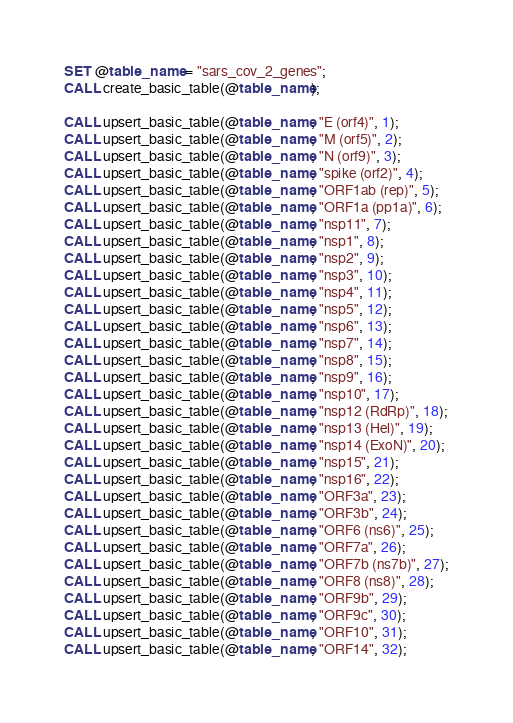Convert code to text. <code><loc_0><loc_0><loc_500><loc_500><_SQL_>SET @table_name = "sars_cov_2_genes";
CALL create_basic_table(@table_name);

CALL upsert_basic_table(@table_name, "E (orf4)", 1);
CALL upsert_basic_table(@table_name, "M (orf5)", 2);
CALL upsert_basic_table(@table_name, "N (orf9)", 3);
CALL upsert_basic_table(@table_name, "spike (orf2)", 4);
CALL upsert_basic_table(@table_name, "ORF1ab (rep)", 5);
CALL upsert_basic_table(@table_name, "ORF1a (pp1a)", 6);
CALL upsert_basic_table(@table_name, "nsp11", 7);
CALL upsert_basic_table(@table_name, "nsp1", 8);
CALL upsert_basic_table(@table_name, "nsp2", 9);
CALL upsert_basic_table(@table_name, "nsp3", 10);
CALL upsert_basic_table(@table_name, "nsp4", 11);
CALL upsert_basic_table(@table_name, "nsp5", 12);
CALL upsert_basic_table(@table_name, "nsp6", 13);
CALL upsert_basic_table(@table_name, "nsp7", 14);
CALL upsert_basic_table(@table_name, "nsp8", 15);
CALL upsert_basic_table(@table_name, "nsp9", 16);
CALL upsert_basic_table(@table_name, "nsp10", 17);
CALL upsert_basic_table(@table_name, "nsp12 (RdRp)", 18);
CALL upsert_basic_table(@table_name, "nsp13 (Hel)", 19);
CALL upsert_basic_table(@table_name, "nsp14 (ExoN)", 20);
CALL upsert_basic_table(@table_name, "nsp15", 21);
CALL upsert_basic_table(@table_name, "nsp16", 22);
CALL upsert_basic_table(@table_name, "ORF3a", 23);
CALL upsert_basic_table(@table_name, "ORF3b", 24);
CALL upsert_basic_table(@table_name, "ORF6 (ns6)", 25);
CALL upsert_basic_table(@table_name, "ORF7a", 26);
CALL upsert_basic_table(@table_name, "ORF7b (ns7b)", 27);
CALL upsert_basic_table(@table_name, "ORF8 (ns8)", 28);
CALL upsert_basic_table(@table_name, "ORF9b", 29);
CALL upsert_basic_table(@table_name, "ORF9c", 30);
CALL upsert_basic_table(@table_name, "ORF10", 31);
CALL upsert_basic_table(@table_name, "ORF14", 32);
</code> 